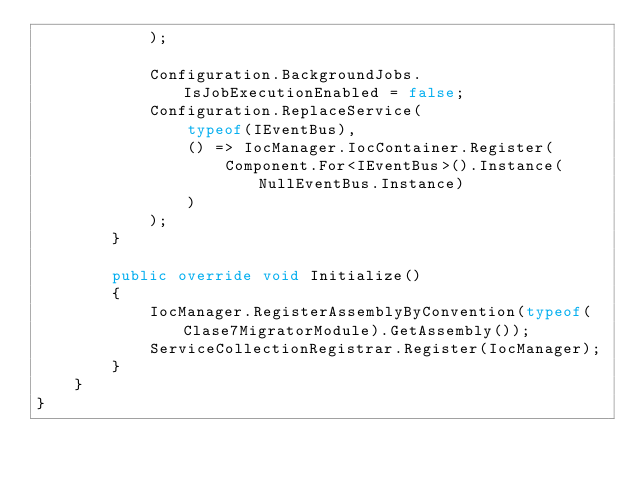<code> <loc_0><loc_0><loc_500><loc_500><_C#_>            );

            Configuration.BackgroundJobs.IsJobExecutionEnabled = false;
            Configuration.ReplaceService(
                typeof(IEventBus), 
                () => IocManager.IocContainer.Register(
                    Component.For<IEventBus>().Instance(NullEventBus.Instance)
                )
            );
        }

        public override void Initialize()
        {
            IocManager.RegisterAssemblyByConvention(typeof(Clase7MigratorModule).GetAssembly());
            ServiceCollectionRegistrar.Register(IocManager);
        }
    }
}
</code> 